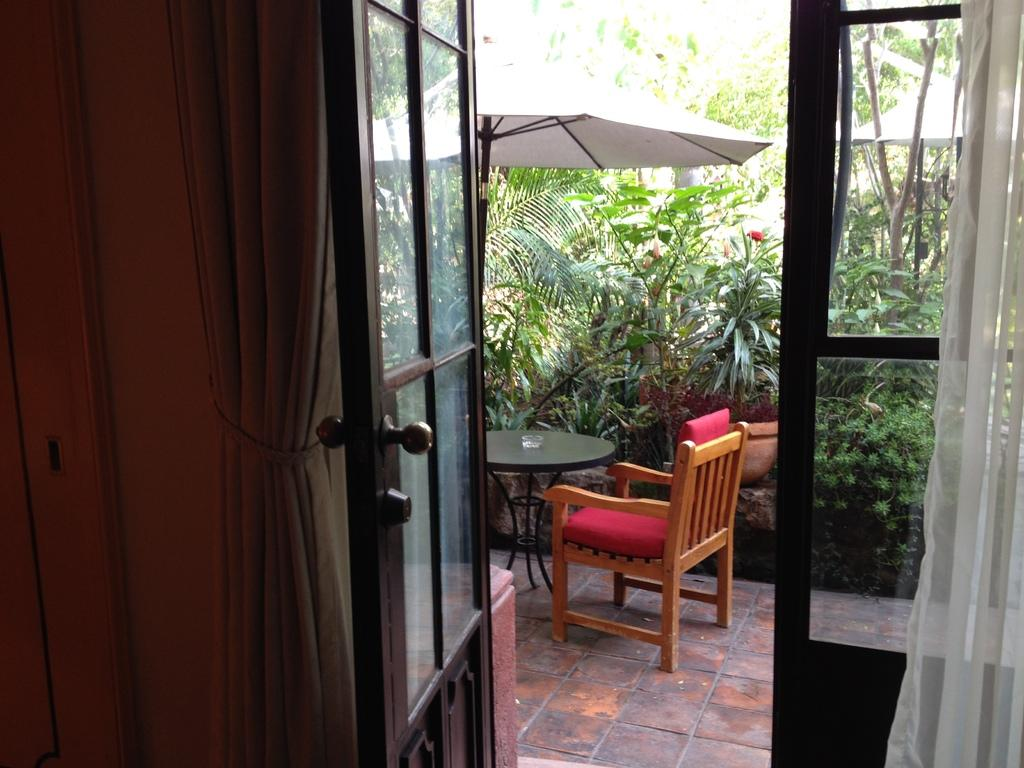What is one of the main objects in the image? There is a door in the image. What is located beside the door? There is a curtain beside the door. What type of furniture can be seen in the image? There is a table and a chair in the image. What can be seen outside the door in the image? There are trees visible in the image. What is an object used for protection from the rain in the image? There is an umbrella in the image. What items on the table might be made of glass? There are glass items on the table. How many dogs are sitting on the chair in the image? There are no dogs present in the image. What achievement is the person in the image celebrating with the umbrella? There is no person in the image, and no achievements are being celebrated. 